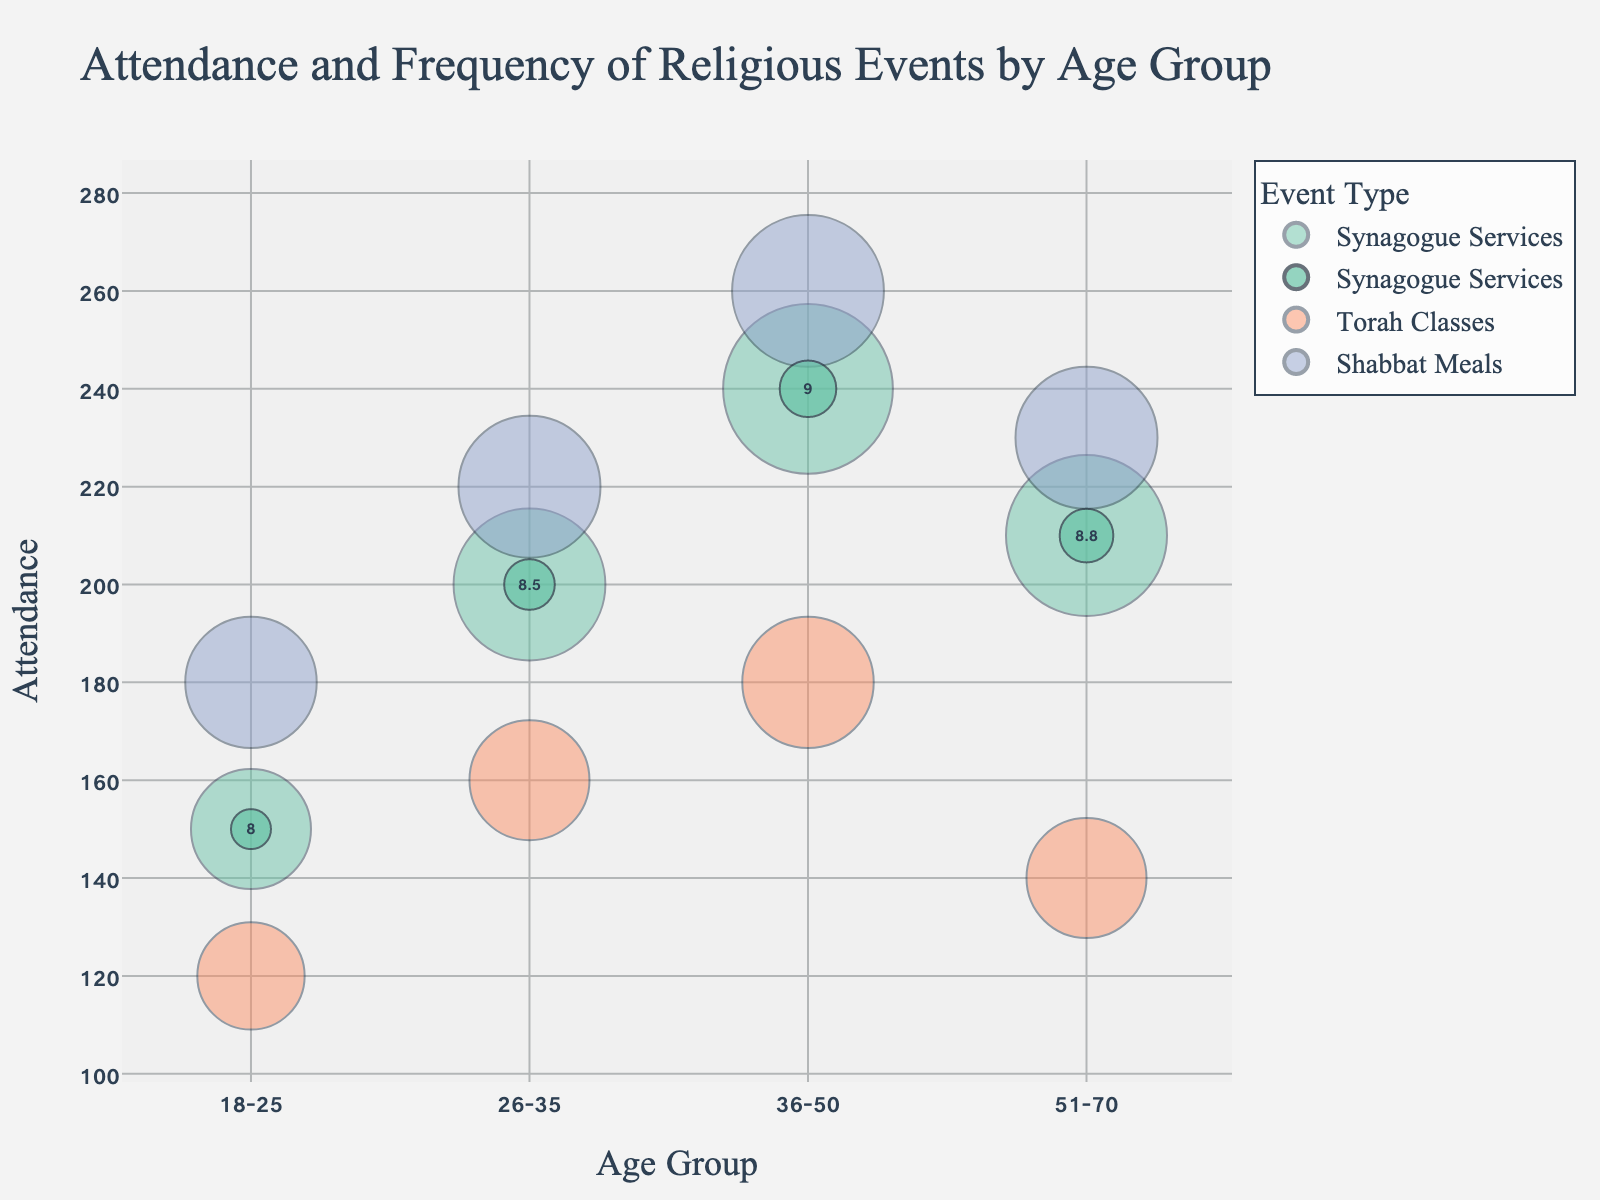What is the title of the chart? The title is displayed at the top of the chart, mentioning both the variables involved and the context of the data.
Answer: Attendance and Frequency of Religious Events by Age Group What color represents Shabbat Meals in the chart? Each event is color-coded distinctly. By examining the legend, you find the color associated with Shabbat Meals.
Answer: Color depends on the palette used but let's say it is green from "Set2" color sequence Which age group has the highest attendance for Torah Classes? By looking at the vertical axis (Attendance) and the event labeled as Torah Classes, the highest value can be observed.
Answer: 36-50 What is the frequency of Synagogue Services for the 26-35 age group? Locate the bubble representing Synagogue Services for the 26-35 age group and check the size to identify the frequency value.
Answer: 40 Compare the attendance of Shabbat Meals between the 18-25 and 51-70 age groups. Which is higher? Locate the bubbles for Shabbat Meals for both age groups and compare their vertical positions (18-25 is 180 and 51-70 is 230).
Answer: 51-70 Which event has the highest popularity score in the 36-50 age group? Hover over or check the annotations inside the bubbles for the 36-50 age group and compare popularity scores for each event type.
Answer: Shabbat Meals How does the attendance of Synagogue Services change among different age groups? Examine the bubbles representing Synagogue Services across all age groups, noting the vertical positions to observe changes.
Answer: It increases from 18-25 to 36-50 and then slightly decreases in 51-70 Which age group attends Torah Classes the least, and what is the corresponding frequency? Locate the age group with the lowest vertical position for Torah Classes and note the size of that bubble.
Answer: 18-25, 20 Are there any age groups where the popularity of Torah Classes is greater than the popularity of Synagogue Services? Compare the text inside the bubbles for Torah Classes and Synagogue Services across all age groups to observe any such conditions.
Answer: No What is the range of attendance for Shabbat Meals across all age groups? Identify the lowest and highest vertical positions of Shabbat Meals bubbles and calculate the difference. The values are 180 to 260. (260-180).
Answer: 80 